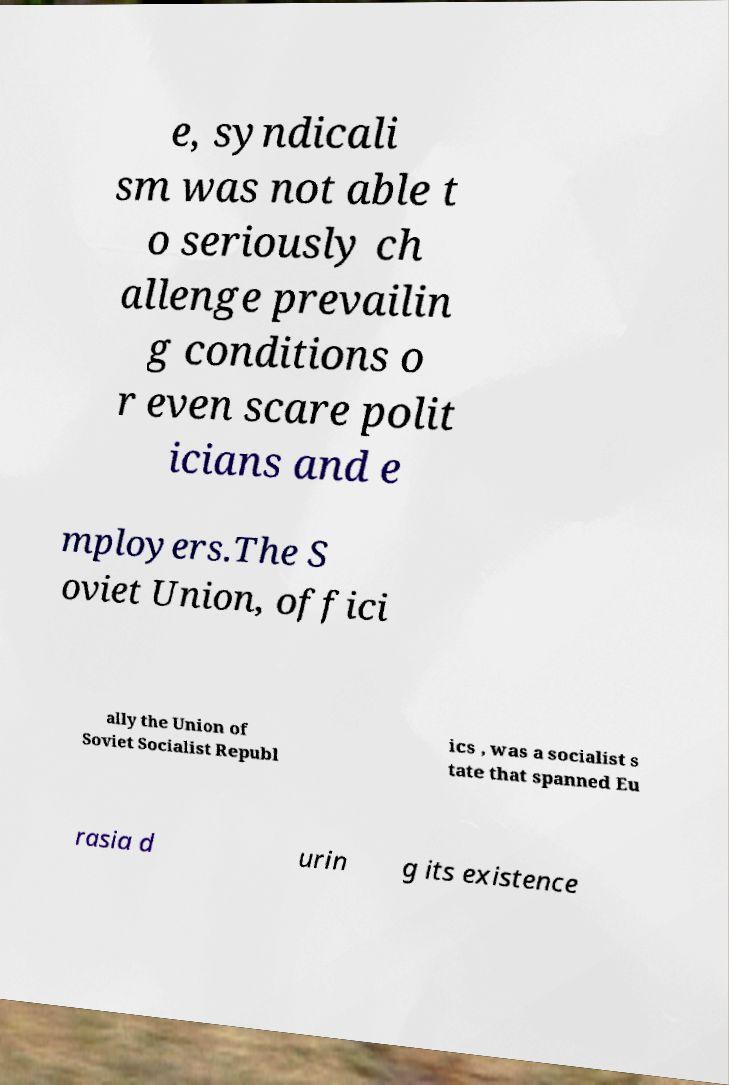Can you accurately transcribe the text from the provided image for me? e, syndicali sm was not able t o seriously ch allenge prevailin g conditions o r even scare polit icians and e mployers.The S oviet Union, offici ally the Union of Soviet Socialist Republ ics , was a socialist s tate that spanned Eu rasia d urin g its existence 